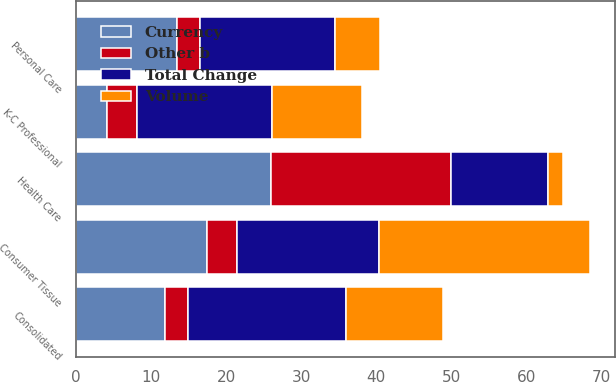Convert chart to OTSL. <chart><loc_0><loc_0><loc_500><loc_500><stacked_bar_chart><ecel><fcel>Consolidated<fcel>Personal Care<fcel>Consumer Tissue<fcel>K-C Professional<fcel>Health Care<nl><fcel>Currency<fcel>11.9<fcel>13.5<fcel>17.4<fcel>4.1<fcel>25.9<nl><fcel>Other b<fcel>3<fcel>3<fcel>4<fcel>4<fcel>24<nl><fcel>Volume<fcel>13<fcel>6<fcel>28<fcel>12<fcel>2<nl><fcel>Total Change<fcel>21<fcel>18<fcel>19<fcel>18<fcel>13<nl></chart> 